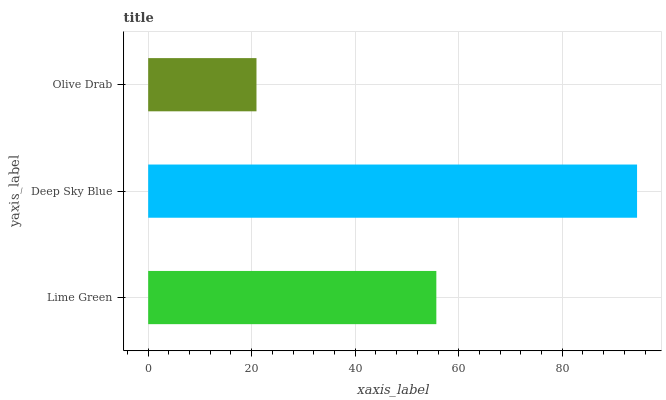Is Olive Drab the minimum?
Answer yes or no. Yes. Is Deep Sky Blue the maximum?
Answer yes or no. Yes. Is Deep Sky Blue the minimum?
Answer yes or no. No. Is Olive Drab the maximum?
Answer yes or no. No. Is Deep Sky Blue greater than Olive Drab?
Answer yes or no. Yes. Is Olive Drab less than Deep Sky Blue?
Answer yes or no. Yes. Is Olive Drab greater than Deep Sky Blue?
Answer yes or no. No. Is Deep Sky Blue less than Olive Drab?
Answer yes or no. No. Is Lime Green the high median?
Answer yes or no. Yes. Is Lime Green the low median?
Answer yes or no. Yes. Is Deep Sky Blue the high median?
Answer yes or no. No. Is Deep Sky Blue the low median?
Answer yes or no. No. 